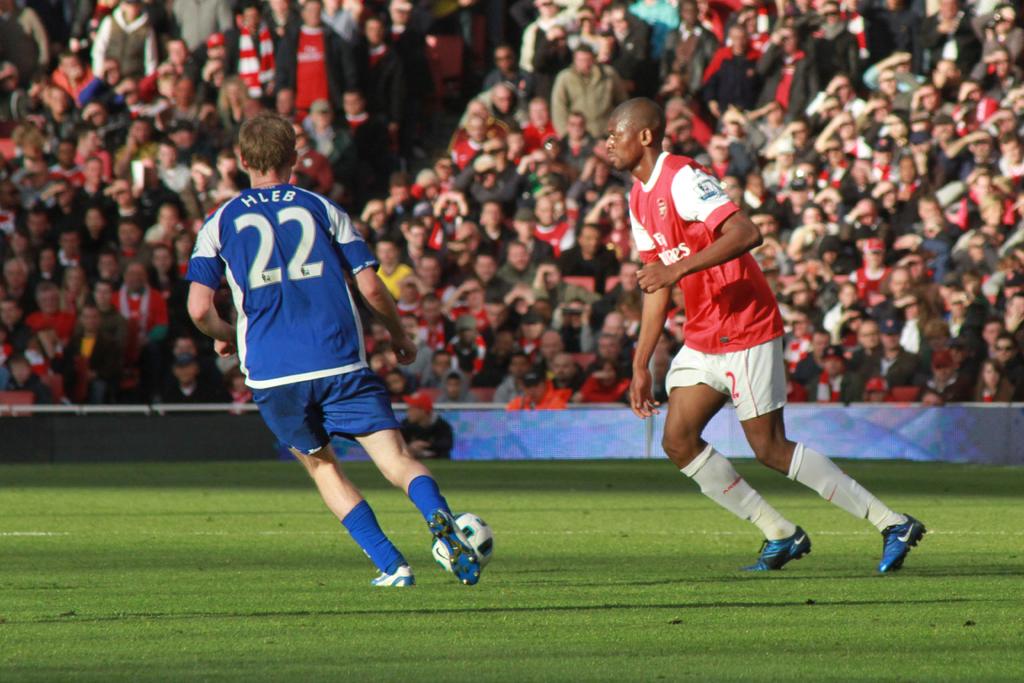What number is the player in blue?
Ensure brevity in your answer.  22. What is the name of the player in blue?
Provide a short and direct response. Hleb. 